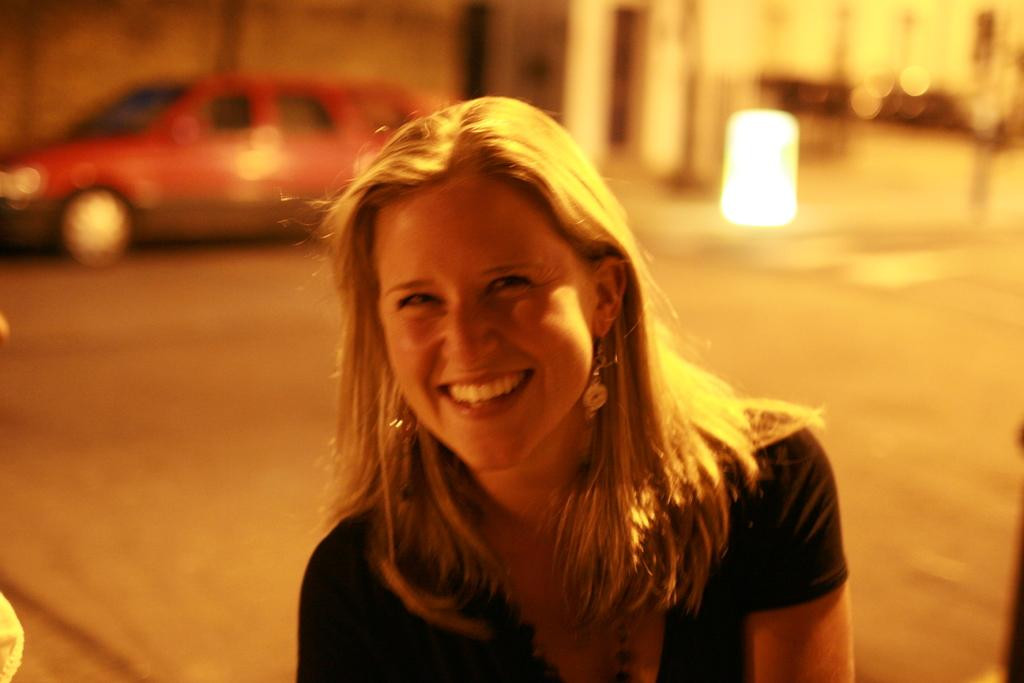Who is the main subject in the image? There is a lady in the center of the image. What is the lady doing in the image? The lady is smiling. What can be seen in the background of the image? There is a car in the background of the image. What type of paper can be seen in the lady's hand in the image? There is no paper visible in the lady's hand in the image. What kind of stone is the lady standing on in the image? The image does not show the lady standing on a stone. 